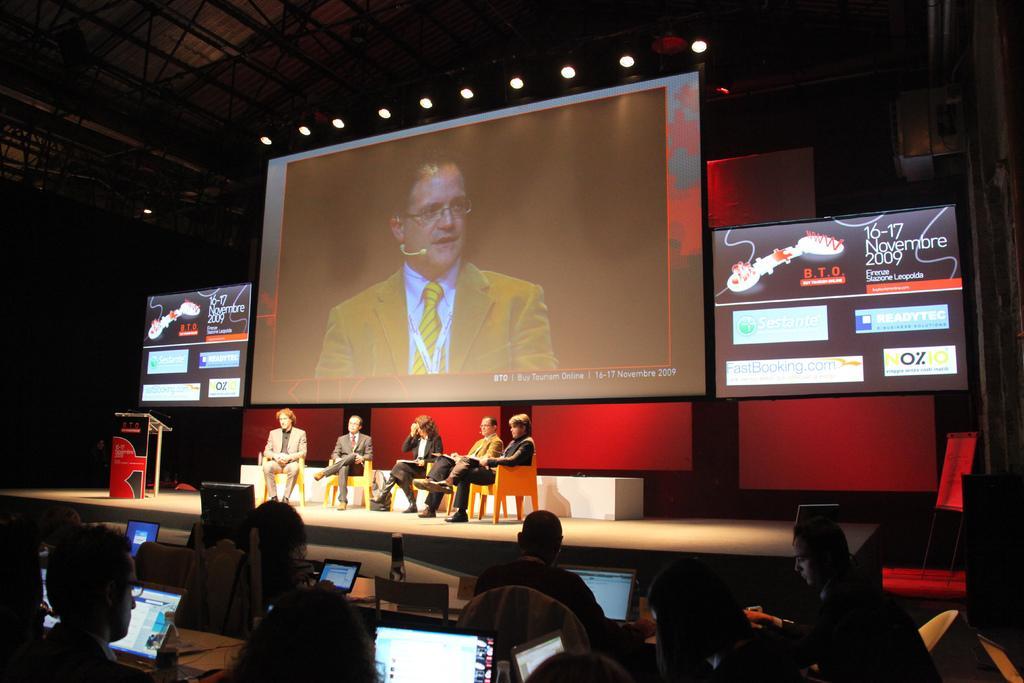Please provide a concise description of this image. In this picture I can observe five members sitting in the chairs on the stage. Behind them there is a screen. In the screen I can observe a man wearing yellow color coat and a tie. In front of the stage there are some people sitting in the chairs in front of laptops and computers. On the left side I can observe a podium on the stage. 